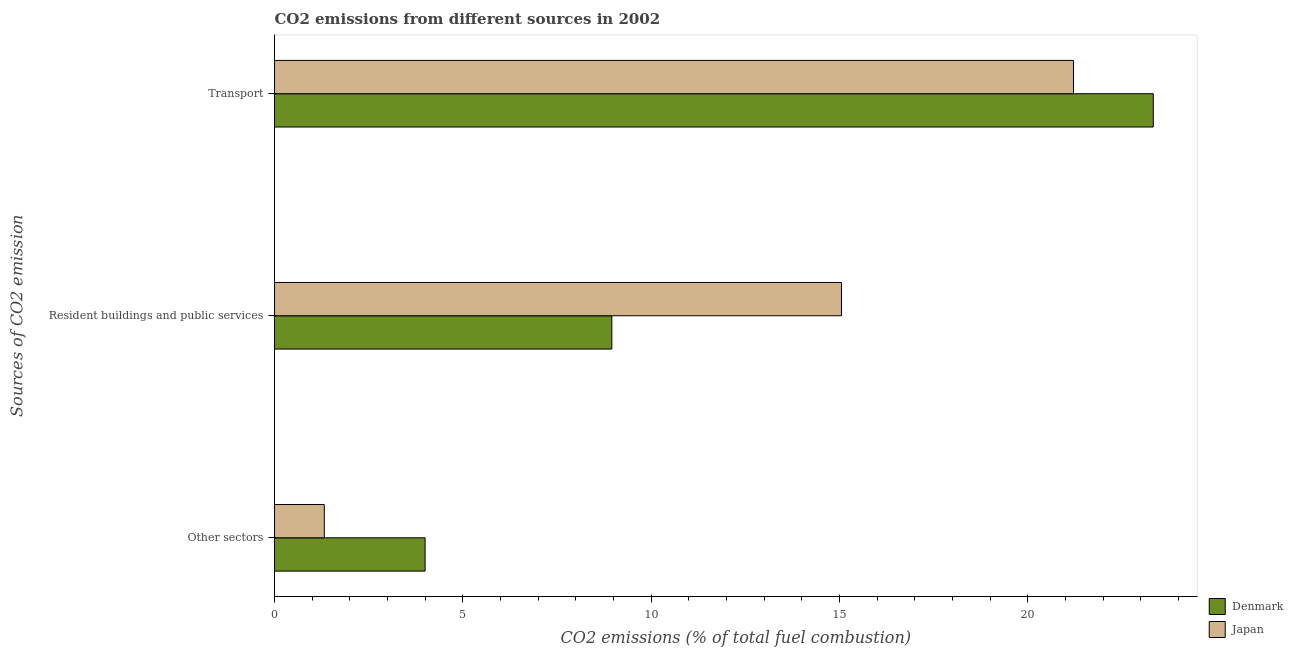How many groups of bars are there?
Provide a short and direct response. 3. Are the number of bars on each tick of the Y-axis equal?
Your answer should be compact. Yes. How many bars are there on the 2nd tick from the top?
Keep it short and to the point. 2. How many bars are there on the 3rd tick from the bottom?
Offer a terse response. 2. What is the label of the 2nd group of bars from the top?
Provide a short and direct response. Resident buildings and public services. What is the percentage of co2 emissions from transport in Japan?
Offer a terse response. 21.21. Across all countries, what is the maximum percentage of co2 emissions from transport?
Make the answer very short. 23.33. Across all countries, what is the minimum percentage of co2 emissions from other sectors?
Ensure brevity in your answer.  1.32. What is the total percentage of co2 emissions from resident buildings and public services in the graph?
Provide a short and direct response. 24.01. What is the difference between the percentage of co2 emissions from transport in Japan and that in Denmark?
Offer a terse response. -2.12. What is the difference between the percentage of co2 emissions from resident buildings and public services in Japan and the percentage of co2 emissions from transport in Denmark?
Offer a terse response. -8.28. What is the average percentage of co2 emissions from resident buildings and public services per country?
Ensure brevity in your answer.  12. What is the difference between the percentage of co2 emissions from transport and percentage of co2 emissions from other sectors in Denmark?
Provide a short and direct response. 19.33. In how many countries, is the percentage of co2 emissions from resident buildings and public services greater than 10 %?
Offer a terse response. 1. What is the ratio of the percentage of co2 emissions from other sectors in Denmark to that in Japan?
Provide a short and direct response. 3.03. What is the difference between the highest and the second highest percentage of co2 emissions from transport?
Your response must be concise. 2.12. What is the difference between the highest and the lowest percentage of co2 emissions from transport?
Provide a short and direct response. 2.12. How many bars are there?
Your answer should be very brief. 6. Are the values on the major ticks of X-axis written in scientific E-notation?
Your answer should be very brief. No. Does the graph contain any zero values?
Ensure brevity in your answer.  No. Does the graph contain grids?
Your response must be concise. No. Where does the legend appear in the graph?
Provide a short and direct response. Bottom right. How many legend labels are there?
Offer a very short reply. 2. What is the title of the graph?
Make the answer very short. CO2 emissions from different sources in 2002. Does "Benin" appear as one of the legend labels in the graph?
Ensure brevity in your answer.  No. What is the label or title of the X-axis?
Your response must be concise. CO2 emissions (% of total fuel combustion). What is the label or title of the Y-axis?
Offer a terse response. Sources of CO2 emission. What is the CO2 emissions (% of total fuel combustion) of Denmark in Other sectors?
Provide a succinct answer. 4. What is the CO2 emissions (% of total fuel combustion) in Japan in Other sectors?
Ensure brevity in your answer.  1.32. What is the CO2 emissions (% of total fuel combustion) in Denmark in Resident buildings and public services?
Make the answer very short. 8.95. What is the CO2 emissions (% of total fuel combustion) of Japan in Resident buildings and public services?
Keep it short and to the point. 15.05. What is the CO2 emissions (% of total fuel combustion) of Denmark in Transport?
Make the answer very short. 23.33. What is the CO2 emissions (% of total fuel combustion) in Japan in Transport?
Keep it short and to the point. 21.21. Across all Sources of CO2 emission, what is the maximum CO2 emissions (% of total fuel combustion) in Denmark?
Your answer should be compact. 23.33. Across all Sources of CO2 emission, what is the maximum CO2 emissions (% of total fuel combustion) in Japan?
Your answer should be very brief. 21.21. Across all Sources of CO2 emission, what is the minimum CO2 emissions (% of total fuel combustion) in Denmark?
Ensure brevity in your answer.  4. Across all Sources of CO2 emission, what is the minimum CO2 emissions (% of total fuel combustion) of Japan?
Your answer should be compact. 1.32. What is the total CO2 emissions (% of total fuel combustion) of Denmark in the graph?
Your response must be concise. 36.28. What is the total CO2 emissions (% of total fuel combustion) of Japan in the graph?
Make the answer very short. 37.58. What is the difference between the CO2 emissions (% of total fuel combustion) of Denmark in Other sectors and that in Resident buildings and public services?
Provide a succinct answer. -4.96. What is the difference between the CO2 emissions (% of total fuel combustion) of Japan in Other sectors and that in Resident buildings and public services?
Offer a terse response. -13.73. What is the difference between the CO2 emissions (% of total fuel combustion) of Denmark in Other sectors and that in Transport?
Ensure brevity in your answer.  -19.33. What is the difference between the CO2 emissions (% of total fuel combustion) of Japan in Other sectors and that in Transport?
Provide a succinct answer. -19.89. What is the difference between the CO2 emissions (% of total fuel combustion) of Denmark in Resident buildings and public services and that in Transport?
Keep it short and to the point. -14.37. What is the difference between the CO2 emissions (% of total fuel combustion) of Japan in Resident buildings and public services and that in Transport?
Provide a short and direct response. -6.16. What is the difference between the CO2 emissions (% of total fuel combustion) of Denmark in Other sectors and the CO2 emissions (% of total fuel combustion) of Japan in Resident buildings and public services?
Your response must be concise. -11.05. What is the difference between the CO2 emissions (% of total fuel combustion) in Denmark in Other sectors and the CO2 emissions (% of total fuel combustion) in Japan in Transport?
Offer a terse response. -17.21. What is the difference between the CO2 emissions (% of total fuel combustion) in Denmark in Resident buildings and public services and the CO2 emissions (% of total fuel combustion) in Japan in Transport?
Offer a terse response. -12.26. What is the average CO2 emissions (% of total fuel combustion) in Denmark per Sources of CO2 emission?
Provide a short and direct response. 12.09. What is the average CO2 emissions (% of total fuel combustion) in Japan per Sources of CO2 emission?
Your answer should be compact. 12.53. What is the difference between the CO2 emissions (% of total fuel combustion) of Denmark and CO2 emissions (% of total fuel combustion) of Japan in Other sectors?
Offer a very short reply. 2.68. What is the difference between the CO2 emissions (% of total fuel combustion) of Denmark and CO2 emissions (% of total fuel combustion) of Japan in Resident buildings and public services?
Ensure brevity in your answer.  -6.1. What is the difference between the CO2 emissions (% of total fuel combustion) of Denmark and CO2 emissions (% of total fuel combustion) of Japan in Transport?
Keep it short and to the point. 2.12. What is the ratio of the CO2 emissions (% of total fuel combustion) of Denmark in Other sectors to that in Resident buildings and public services?
Provide a succinct answer. 0.45. What is the ratio of the CO2 emissions (% of total fuel combustion) in Japan in Other sectors to that in Resident buildings and public services?
Make the answer very short. 0.09. What is the ratio of the CO2 emissions (% of total fuel combustion) of Denmark in Other sectors to that in Transport?
Ensure brevity in your answer.  0.17. What is the ratio of the CO2 emissions (% of total fuel combustion) in Japan in Other sectors to that in Transport?
Your answer should be very brief. 0.06. What is the ratio of the CO2 emissions (% of total fuel combustion) of Denmark in Resident buildings and public services to that in Transport?
Offer a very short reply. 0.38. What is the ratio of the CO2 emissions (% of total fuel combustion) in Japan in Resident buildings and public services to that in Transport?
Give a very brief answer. 0.71. What is the difference between the highest and the second highest CO2 emissions (% of total fuel combustion) of Denmark?
Provide a short and direct response. 14.37. What is the difference between the highest and the second highest CO2 emissions (% of total fuel combustion) in Japan?
Make the answer very short. 6.16. What is the difference between the highest and the lowest CO2 emissions (% of total fuel combustion) of Denmark?
Your answer should be compact. 19.33. What is the difference between the highest and the lowest CO2 emissions (% of total fuel combustion) in Japan?
Provide a succinct answer. 19.89. 